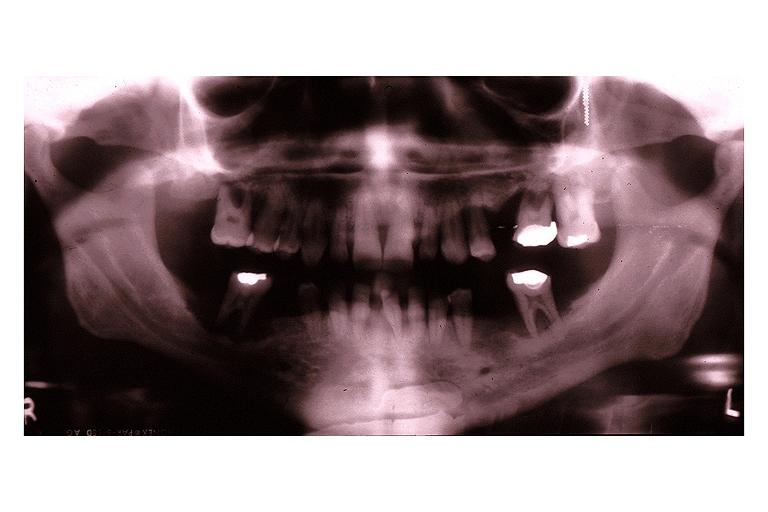what does this image show?
Answer the question using a single word or phrase. Langerhans cell histiocytosis eosinophilic granuloma 